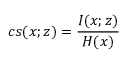<formula> <loc_0><loc_0><loc_500><loc_500>c s ( x ; z ) = \frac { I ( x ; z ) } { H ( x ) }</formula> 